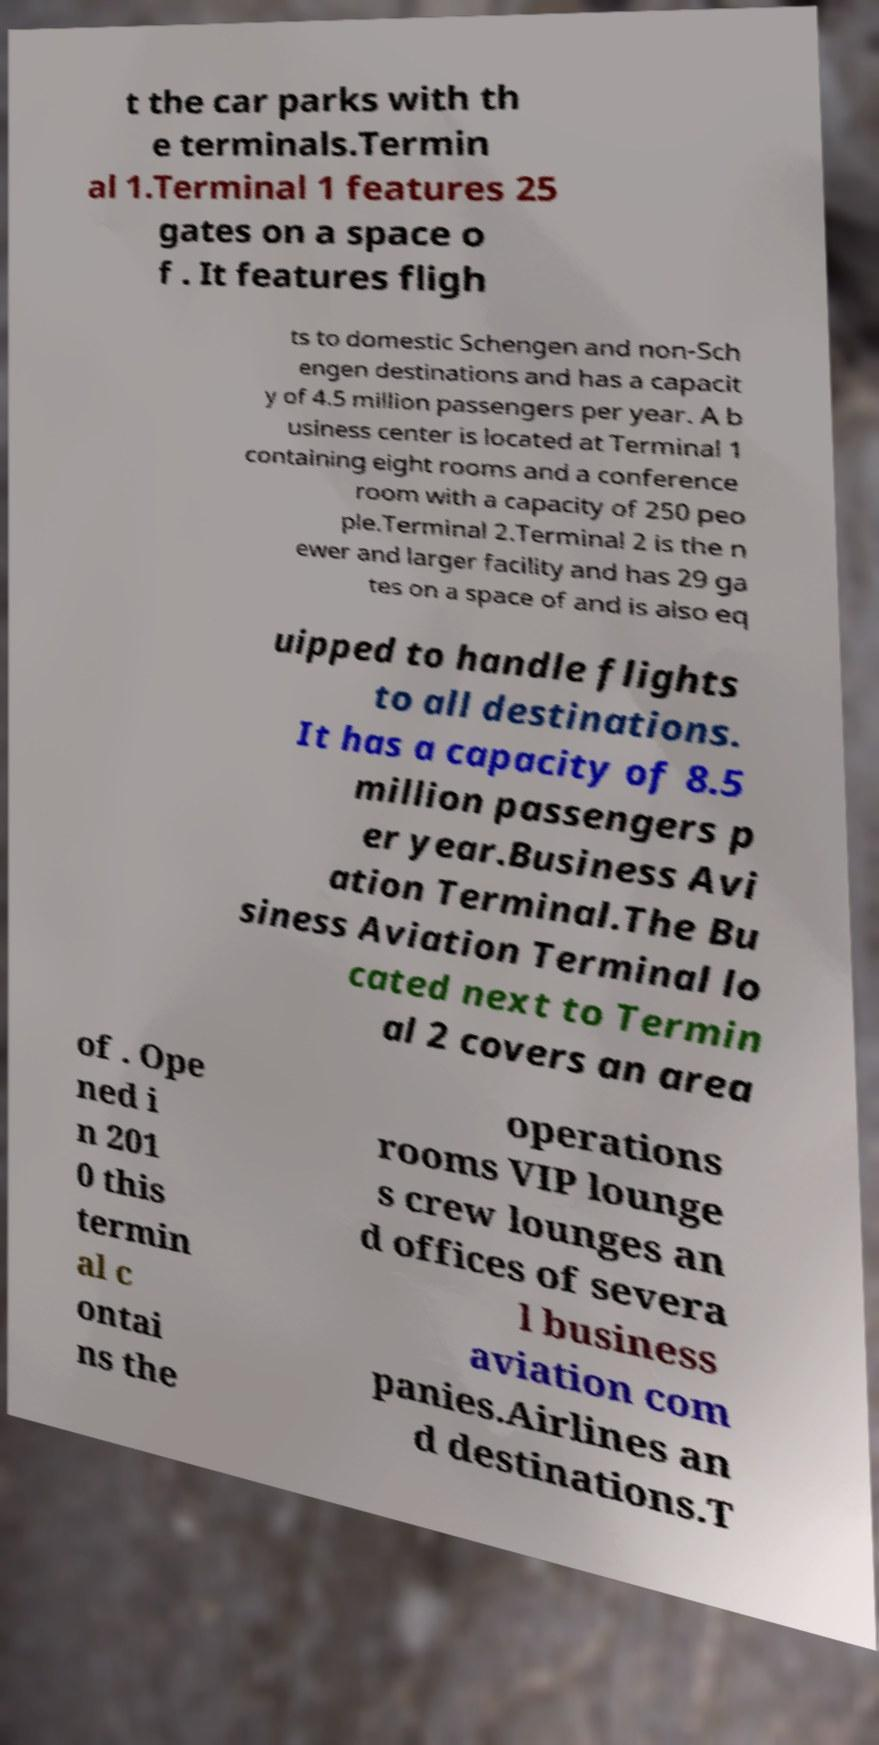Could you extract and type out the text from this image? t the car parks with th e terminals.Termin al 1.Terminal 1 features 25 gates on a space o f . It features fligh ts to domestic Schengen and non-Sch engen destinations and has a capacit y of 4.5 million passengers per year. A b usiness center is located at Terminal 1 containing eight rooms and a conference room with a capacity of 250 peo ple.Terminal 2.Terminal 2 is the n ewer and larger facility and has 29 ga tes on a space of and is also eq uipped to handle flights to all destinations. It has a capacity of 8.5 million passengers p er year.Business Avi ation Terminal.The Bu siness Aviation Terminal lo cated next to Termin al 2 covers an area of . Ope ned i n 201 0 this termin al c ontai ns the operations rooms VIP lounge s crew lounges an d offices of severa l business aviation com panies.Airlines an d destinations.T 